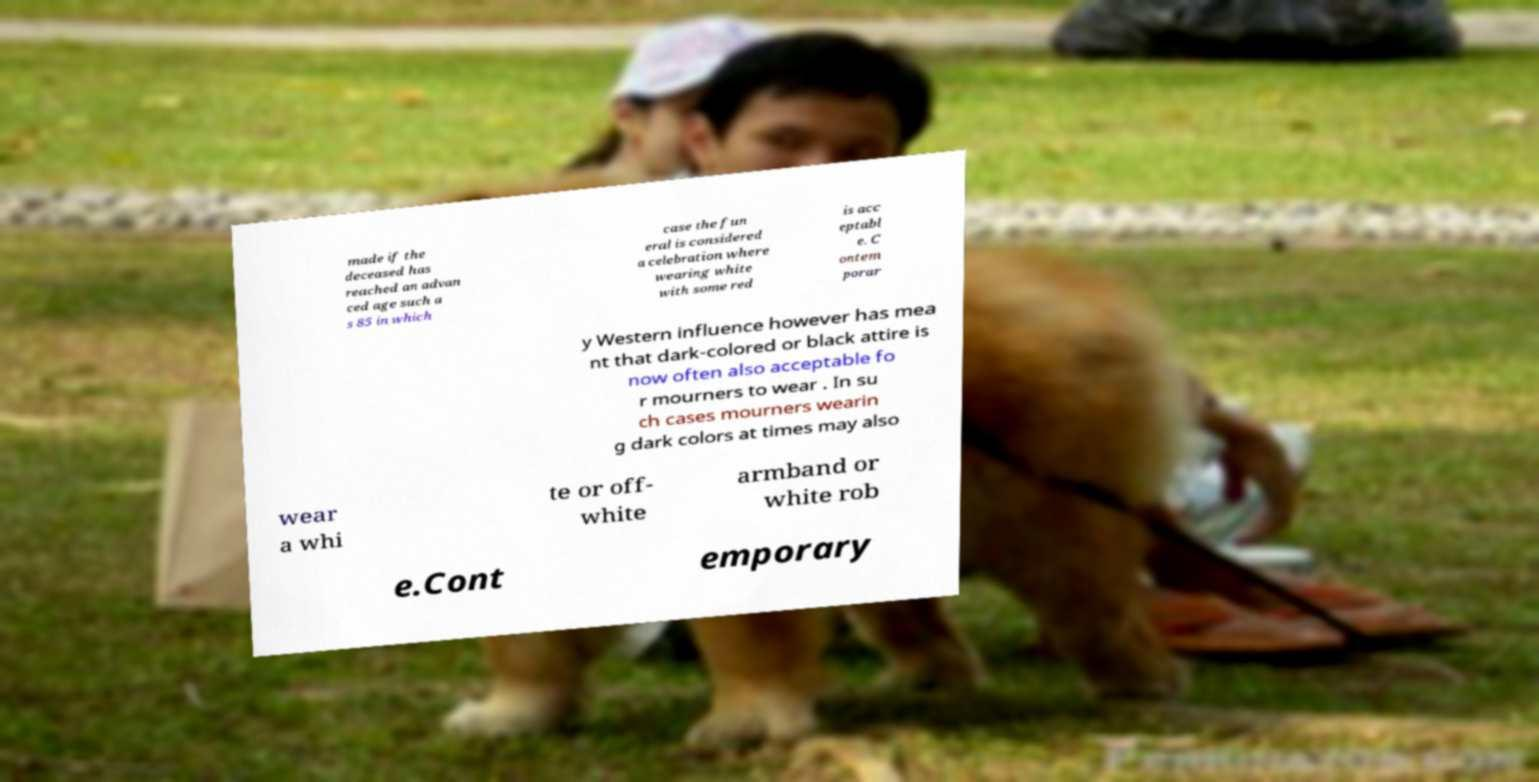Can you read and provide the text displayed in the image?This photo seems to have some interesting text. Can you extract and type it out for me? made if the deceased has reached an advan ced age such a s 85 in which case the fun eral is considered a celebration where wearing white with some red is acc eptabl e. C ontem porar y Western influence however has mea nt that dark-colored or black attire is now often also acceptable fo r mourners to wear . In su ch cases mourners wearin g dark colors at times may also wear a whi te or off- white armband or white rob e.Cont emporary 